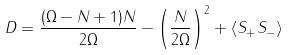<formula> <loc_0><loc_0><loc_500><loc_500>D = \frac { ( \Omega - N + 1 ) N } { 2 \Omega } - \left ( \frac { N } { 2 \Omega } \right ) ^ { 2 } + \langle S _ { + } S _ { - } \rangle</formula> 